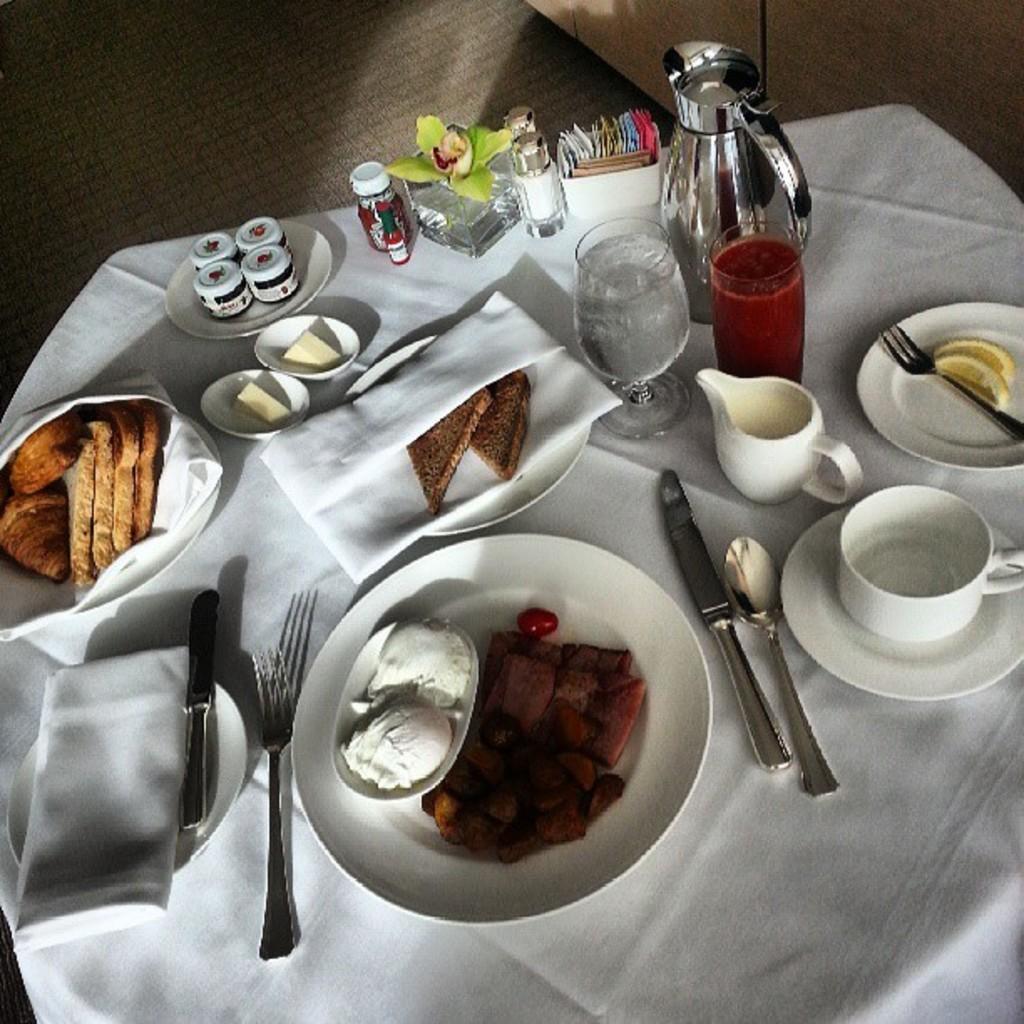Can you describe this image briefly? In this picture there is a table in the center which is covered with white a colour cloth. On the table there are spoon, knife, fork. There are some food on the plates, glasses, jar, cup, and small bottles. 